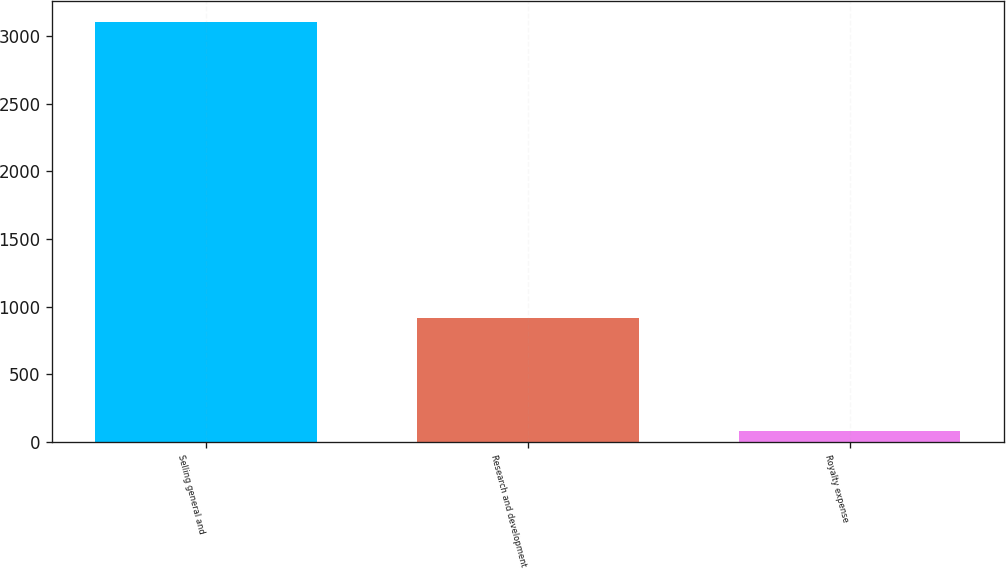Convert chart to OTSL. <chart><loc_0><loc_0><loc_500><loc_500><bar_chart><fcel>Selling general and<fcel>Research and development<fcel>Royalty expense<nl><fcel>3099<fcel>920<fcel>79<nl></chart> 